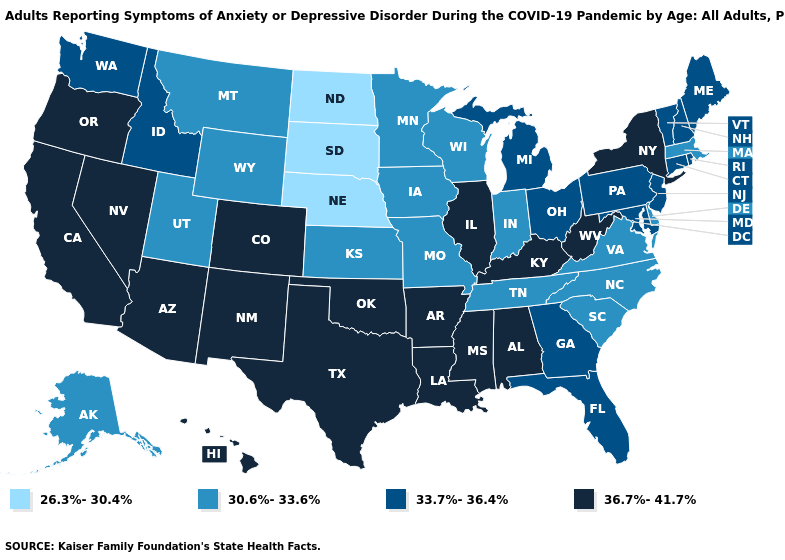What is the lowest value in states that border Massachusetts?
Answer briefly. 33.7%-36.4%. What is the value of Minnesota?
Write a very short answer. 30.6%-33.6%. What is the value of Minnesota?
Give a very brief answer. 30.6%-33.6%. What is the value of Kentucky?
Keep it brief. 36.7%-41.7%. Name the states that have a value in the range 36.7%-41.7%?
Give a very brief answer. Alabama, Arizona, Arkansas, California, Colorado, Hawaii, Illinois, Kentucky, Louisiana, Mississippi, Nevada, New Mexico, New York, Oklahoma, Oregon, Texas, West Virginia. Among the states that border Alabama , which have the highest value?
Give a very brief answer. Mississippi. Name the states that have a value in the range 33.7%-36.4%?
Concise answer only. Connecticut, Florida, Georgia, Idaho, Maine, Maryland, Michigan, New Hampshire, New Jersey, Ohio, Pennsylvania, Rhode Island, Vermont, Washington. Among the states that border Pennsylvania , which have the highest value?
Quick response, please. New York, West Virginia. Does Utah have the lowest value in the West?
Concise answer only. Yes. Name the states that have a value in the range 36.7%-41.7%?
Concise answer only. Alabama, Arizona, Arkansas, California, Colorado, Hawaii, Illinois, Kentucky, Louisiana, Mississippi, Nevada, New Mexico, New York, Oklahoma, Oregon, Texas, West Virginia. What is the highest value in the South ?
Answer briefly. 36.7%-41.7%. Does Idaho have the same value as Colorado?
Short answer required. No. Which states have the lowest value in the Northeast?
Give a very brief answer. Massachusetts. Does the first symbol in the legend represent the smallest category?
Answer briefly. Yes. Does the first symbol in the legend represent the smallest category?
Short answer required. Yes. 